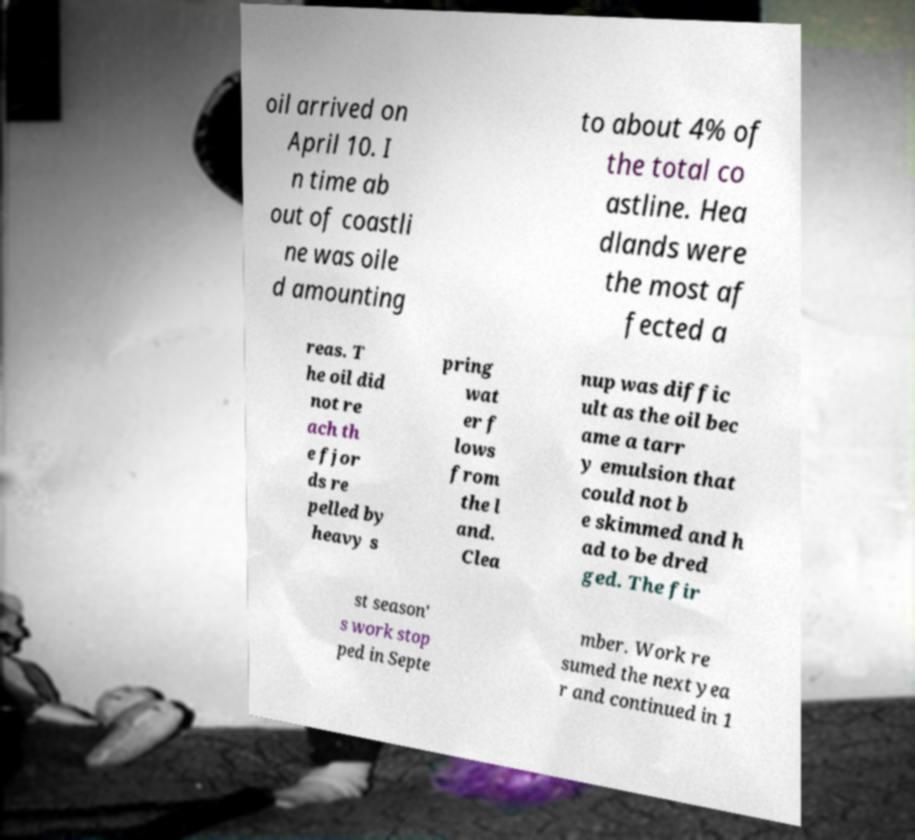Can you read and provide the text displayed in the image?This photo seems to have some interesting text. Can you extract and type it out for me? oil arrived on April 10. I n time ab out of coastli ne was oile d amounting to about 4% of the total co astline. Hea dlands were the most af fected a reas. T he oil did not re ach th e fjor ds re pelled by heavy s pring wat er f lows from the l and. Clea nup was diffic ult as the oil bec ame a tarr y emulsion that could not b e skimmed and h ad to be dred ged. The fir st season' s work stop ped in Septe mber. Work re sumed the next yea r and continued in 1 